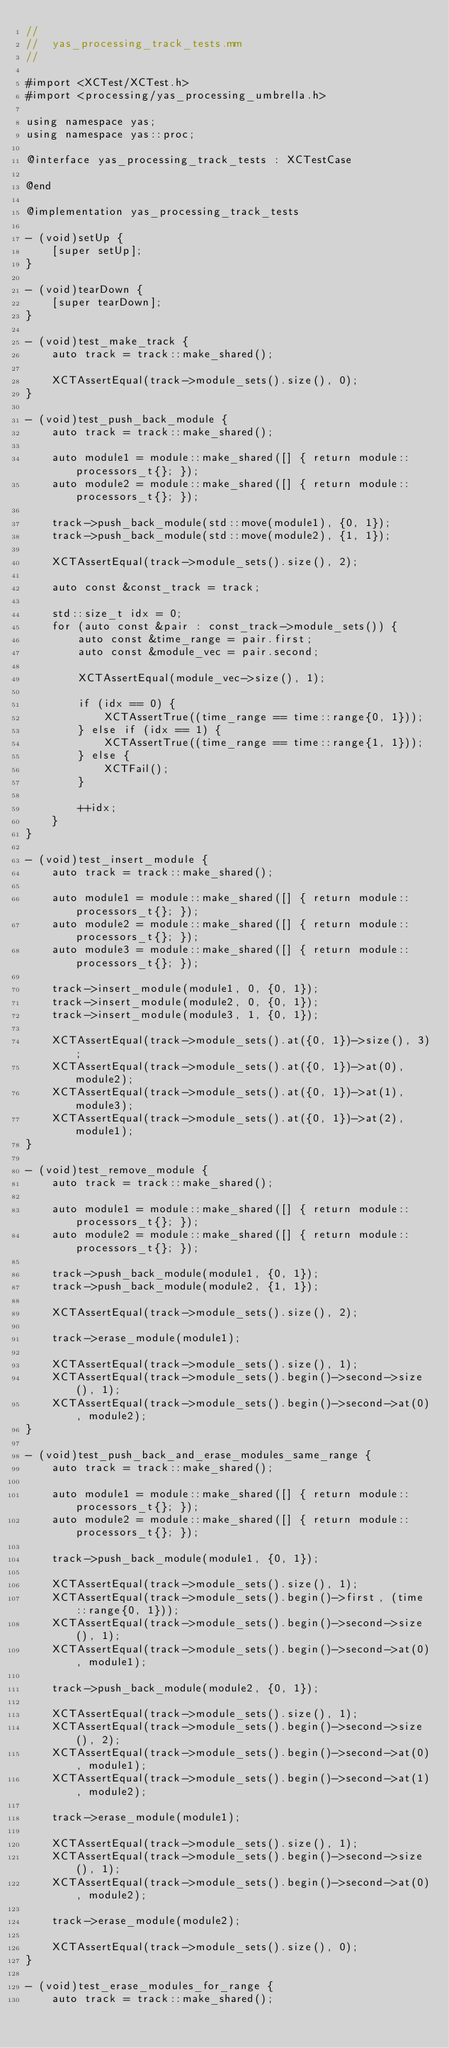Convert code to text. <code><loc_0><loc_0><loc_500><loc_500><_ObjectiveC_>//
//  yas_processing_track_tests.mm
//

#import <XCTest/XCTest.h>
#import <processing/yas_processing_umbrella.h>

using namespace yas;
using namespace yas::proc;

@interface yas_processing_track_tests : XCTestCase

@end

@implementation yas_processing_track_tests

- (void)setUp {
    [super setUp];
}

- (void)tearDown {
    [super tearDown];
}

- (void)test_make_track {
    auto track = track::make_shared();

    XCTAssertEqual(track->module_sets().size(), 0);
}

- (void)test_push_back_module {
    auto track = track::make_shared();

    auto module1 = module::make_shared([] { return module::processors_t{}; });
    auto module2 = module::make_shared([] { return module::processors_t{}; });

    track->push_back_module(std::move(module1), {0, 1});
    track->push_back_module(std::move(module2), {1, 1});

    XCTAssertEqual(track->module_sets().size(), 2);

    auto const &const_track = track;

    std::size_t idx = 0;
    for (auto const &pair : const_track->module_sets()) {
        auto const &time_range = pair.first;
        auto const &module_vec = pair.second;

        XCTAssertEqual(module_vec->size(), 1);

        if (idx == 0) {
            XCTAssertTrue((time_range == time::range{0, 1}));
        } else if (idx == 1) {
            XCTAssertTrue((time_range == time::range{1, 1}));
        } else {
            XCTFail();
        }

        ++idx;
    }
}

- (void)test_insert_module {
    auto track = track::make_shared();

    auto module1 = module::make_shared([] { return module::processors_t{}; });
    auto module2 = module::make_shared([] { return module::processors_t{}; });
    auto module3 = module::make_shared([] { return module::processors_t{}; });

    track->insert_module(module1, 0, {0, 1});
    track->insert_module(module2, 0, {0, 1});
    track->insert_module(module3, 1, {0, 1});

    XCTAssertEqual(track->module_sets().at({0, 1})->size(), 3);
    XCTAssertEqual(track->module_sets().at({0, 1})->at(0), module2);
    XCTAssertEqual(track->module_sets().at({0, 1})->at(1), module3);
    XCTAssertEqual(track->module_sets().at({0, 1})->at(2), module1);
}

- (void)test_remove_module {
    auto track = track::make_shared();

    auto module1 = module::make_shared([] { return module::processors_t{}; });
    auto module2 = module::make_shared([] { return module::processors_t{}; });

    track->push_back_module(module1, {0, 1});
    track->push_back_module(module2, {1, 1});

    XCTAssertEqual(track->module_sets().size(), 2);

    track->erase_module(module1);

    XCTAssertEqual(track->module_sets().size(), 1);
    XCTAssertEqual(track->module_sets().begin()->second->size(), 1);
    XCTAssertEqual(track->module_sets().begin()->second->at(0), module2);
}

- (void)test_push_back_and_erase_modules_same_range {
    auto track = track::make_shared();

    auto module1 = module::make_shared([] { return module::processors_t{}; });
    auto module2 = module::make_shared([] { return module::processors_t{}; });

    track->push_back_module(module1, {0, 1});

    XCTAssertEqual(track->module_sets().size(), 1);
    XCTAssertEqual(track->module_sets().begin()->first, (time::range{0, 1}));
    XCTAssertEqual(track->module_sets().begin()->second->size(), 1);
    XCTAssertEqual(track->module_sets().begin()->second->at(0), module1);

    track->push_back_module(module2, {0, 1});

    XCTAssertEqual(track->module_sets().size(), 1);
    XCTAssertEqual(track->module_sets().begin()->second->size(), 2);
    XCTAssertEqual(track->module_sets().begin()->second->at(0), module1);
    XCTAssertEqual(track->module_sets().begin()->second->at(1), module2);

    track->erase_module(module1);

    XCTAssertEqual(track->module_sets().size(), 1);
    XCTAssertEqual(track->module_sets().begin()->second->size(), 1);
    XCTAssertEqual(track->module_sets().begin()->second->at(0), module2);

    track->erase_module(module2);

    XCTAssertEqual(track->module_sets().size(), 0);
}

- (void)test_erase_modules_for_range {
    auto track = track::make_shared();
</code> 